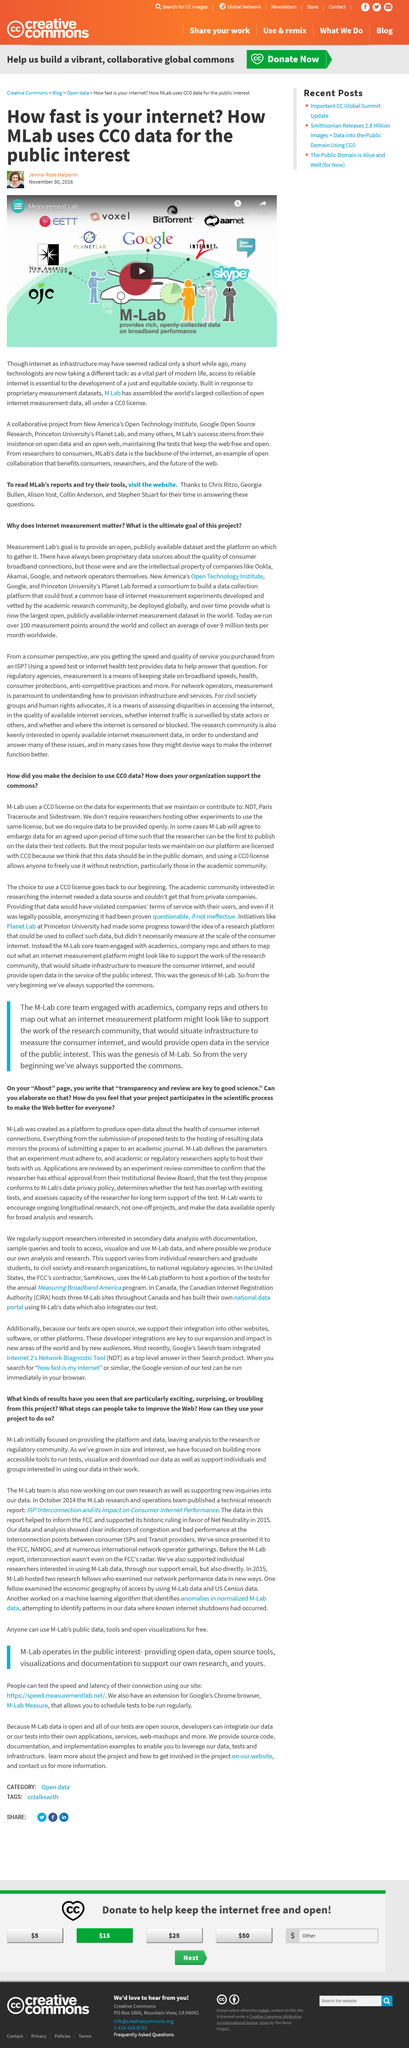Specify some key components in this picture. Access to reliable internet is a critical component of a just and equitable society, and its availability is essential for the advancement of social and economic opportunities. Jennie Rose Halperin wrote the article titled "How fast is your internet? How MLab uses CCO data for the public interest. M Lab has assembled the world's largest collection of open internet measurement data, which is all available under a CCO license. 